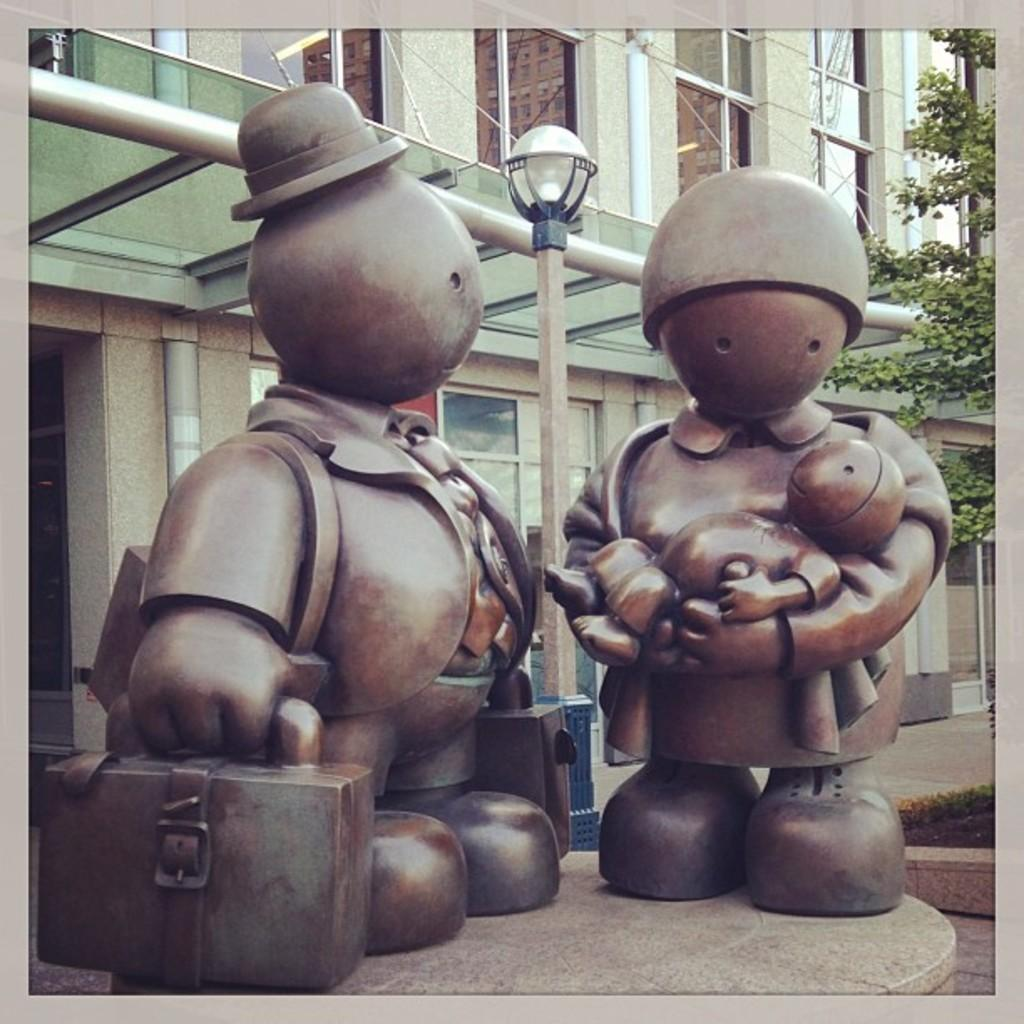What can be seen in front of the building in the image? There are sculptures in front of the building. What is located in the middle of the image? There is a pole in the middle of the image. What type of vegetation is on the right side of the image? There is a branch on the right side of the image. What type of pie is being served in the library in the image? There is no pie or library present in the image; it features sculptures, a pole, and a branch. How does the steam escape from the sculptures in the image? There is no steam present in the image; it only features sculptures, a pole, and a branch. 